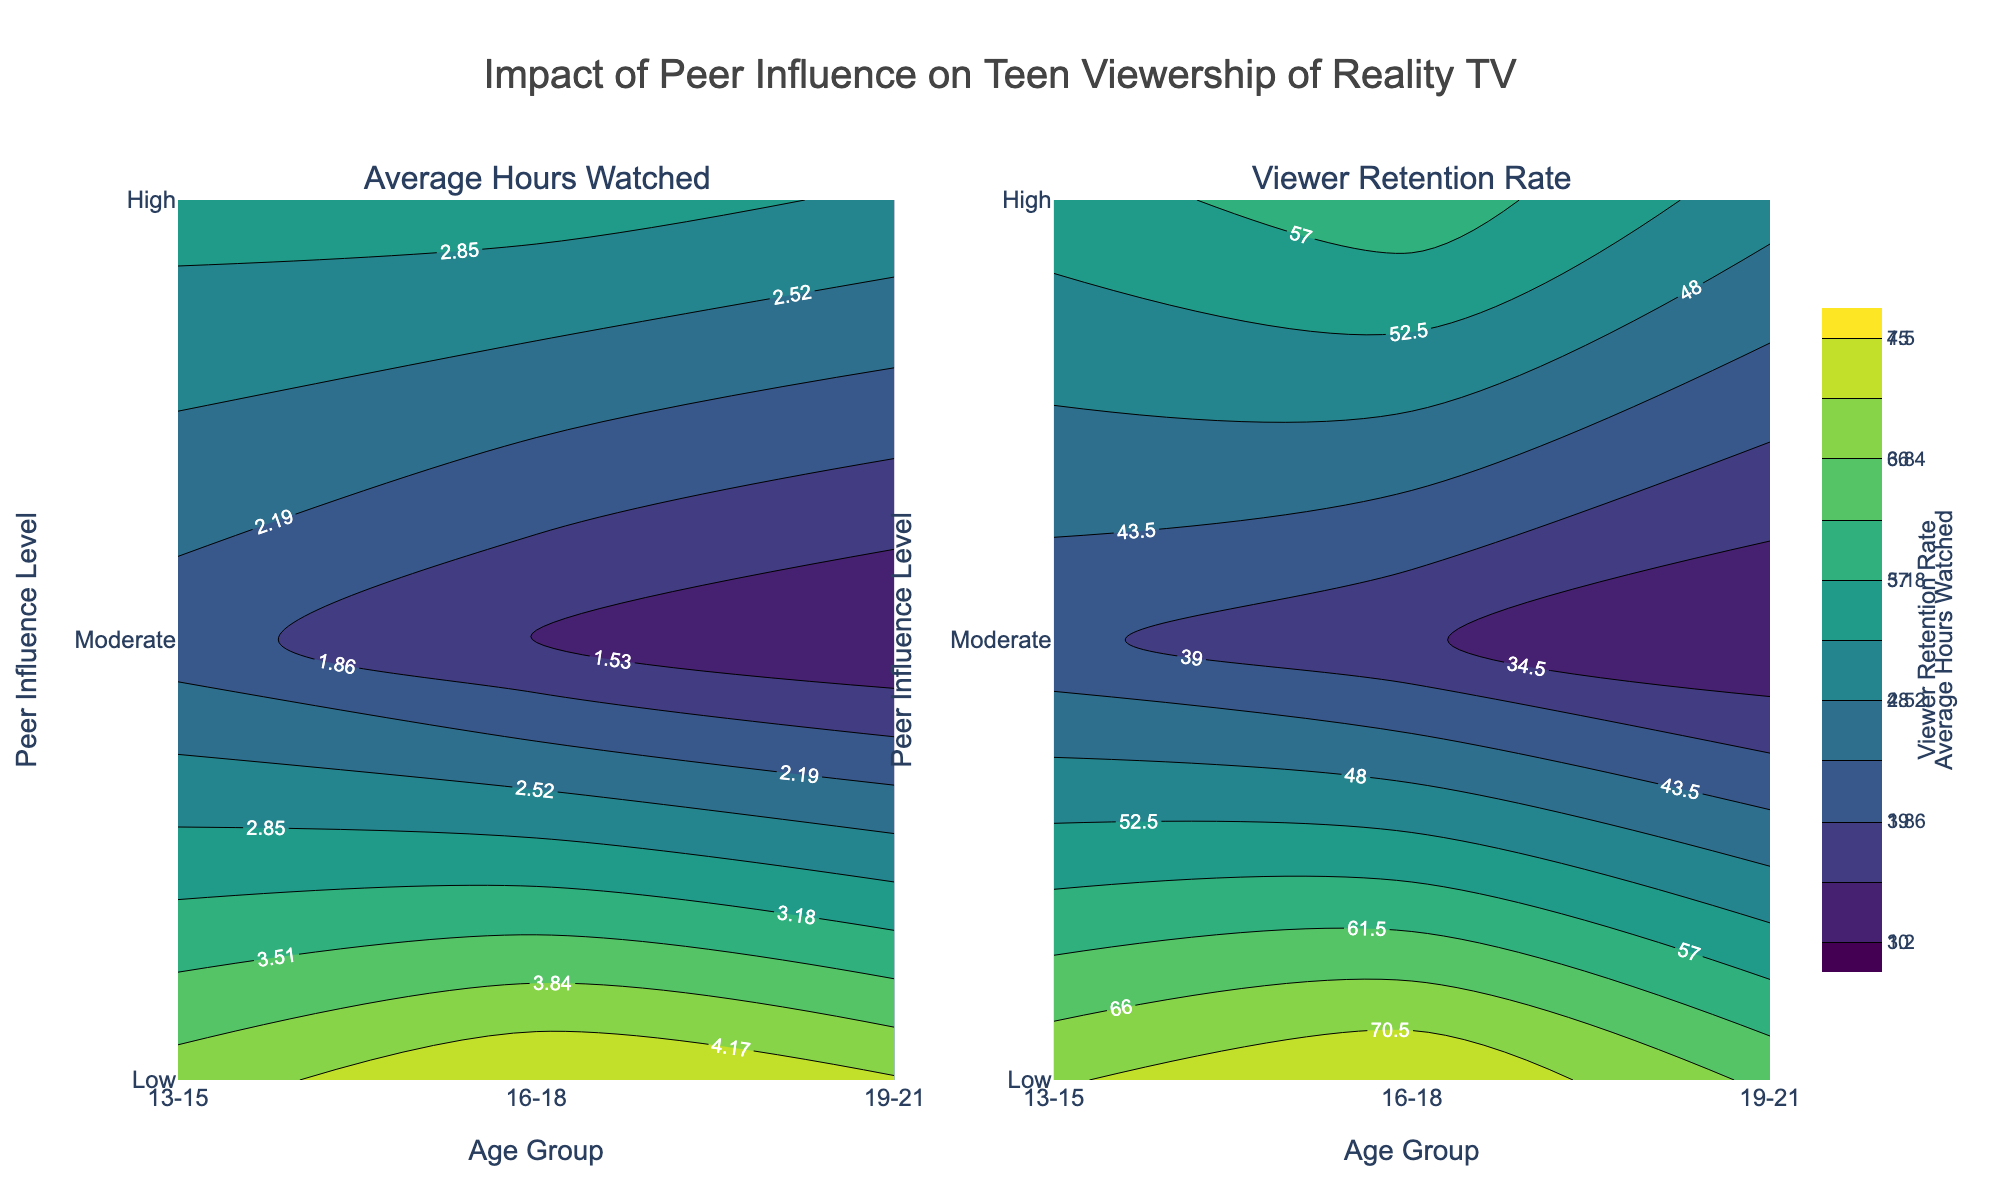What is the title of the figure? The title of the figure is displayed at the top center. It states, "Impact of Peer Influence on Teen Viewership of Reality TV."
Answer: Impact of Peer Influence on Teen Viewership of Reality TV What do the two contour plots in the figure represent? The subplot titles indicate that the left contour plot represents "Average Hours Watched," while the right contour plot represents "Viewer Retention Rate."
Answer: Average Hours Watched and Viewer Retention Rate Which age group and influence level combination has the highest average hours watched? By looking at the contour plot for "Average Hours Watched," the highest value corresponds to the intersection of age group 16-18 and high peer influence level.
Answer: 16-18 and High How does the viewer retention rate change for the 19-21 age group as peer influence level increases? In the contour plot for "Viewer Retention Rate," for the 19-21 age group, the rate increases from 30 at low influence to 50 at moderate influence to 65 at high influence.
Answer: Increases What is the difference in average hours watched between the lowest and highest peer influence levels for the 13-15 age group? In the "Average Hours Watched" plot, it shows 2 hours for low influence and 4 hours for high influence for the 13-15 age group. The difference is 4 - 2 = 2 hours.
Answer: 2 hours Which peer influence level results in the highest viewer retention rate for any age group? The "Viewer Retention Rate" plot shows that for the age group 16-18 with high peer influence, the retention rate is the highest at 75.
Answer: High For the age group 16-18, how much does the average hours watched increase as peer influence level changes from low to moderate to high? For the 16-18 age group in the "Average Hours Watched" plot, the hours increase from 1.5 to 3 to 4.5. The increases are 3 - 1.5 = 1.5 hours when going from low to moderate, and 4.5 - 3 = 1.5 hours when going from moderate to high. Total increase is 1.5 + 1.5 = 3 hours.
Answer: 3 hours What color is predominantly used in areas of highest retention rate on the "Viewer Retention Rate" plot? The highest retention rate areas on the "Viewer Retention Rate" plot use a color close to bright yellow or light green.
Answer: Bright yellow / Light green 